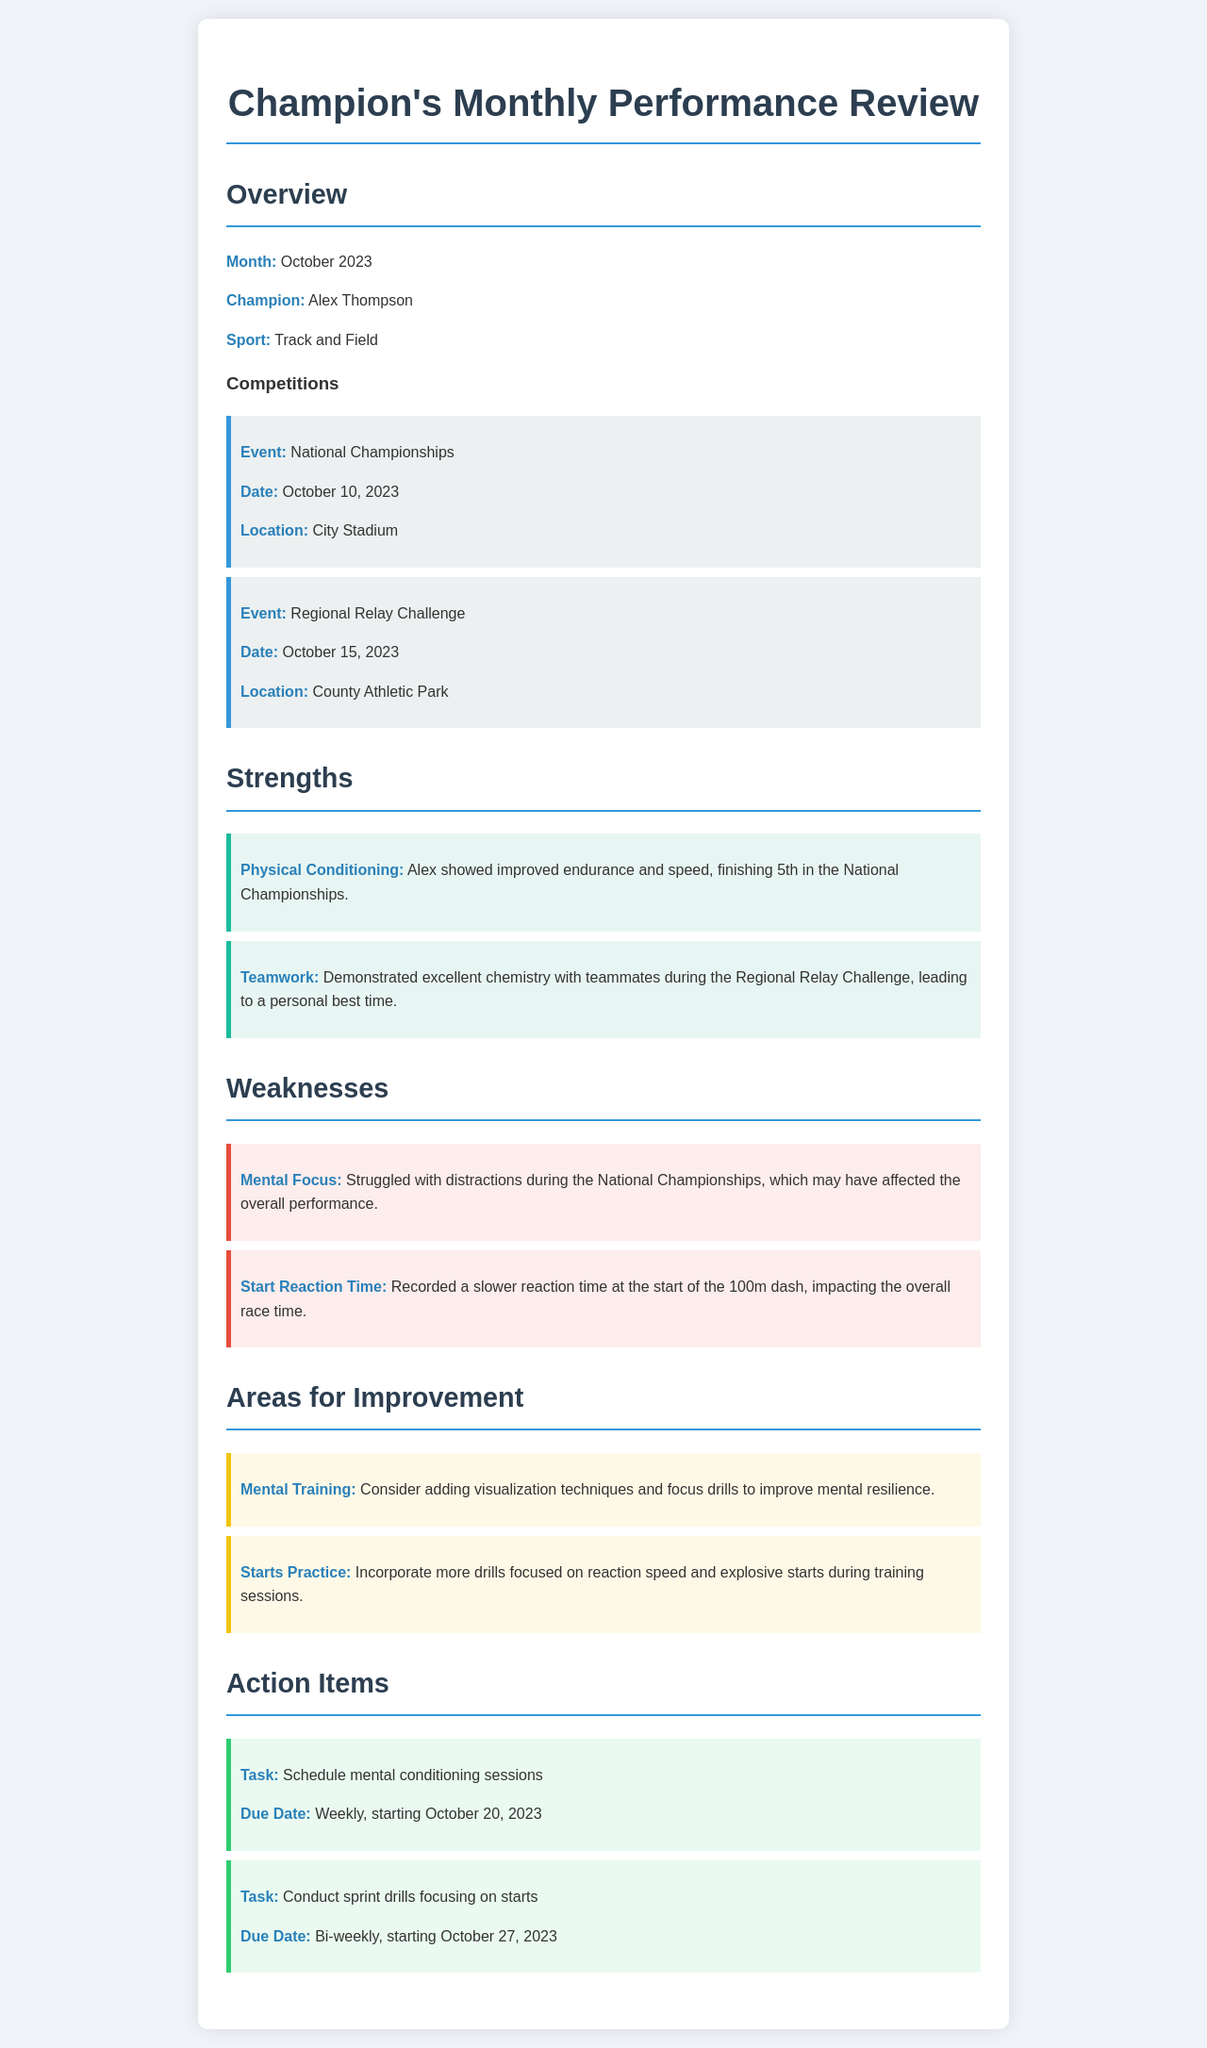What is the name of the champion? The champion's name is mentioned in the overview section of the document.
Answer: Alex Thompson What event did Alex compete in on October 10, 2023? The event includes specific details regarding competitions held, especially the one on October 10.
Answer: National Championships What was Alex's placement at the National Championships? Alex's standing in the National Championships is clearly stated in the strengths section.
Answer: 5th What was identified as a weakness regarding Alex's performance? The weaknesses section lists specific areas where Alex can improve.
Answer: Mental Focus What specific area of improvement involves visualization techniques? The document outlines improvement areas, highlighting specific strategies to enhance performance.
Answer: Mental Training How often are mental conditioning sessions scheduled? The action items section specifies the frequency for different tasks.
Answer: Weekly What location hosted the Regional Relay Challenge? The document specifies the location of each competitive event, including this one.
Answer: County Athletic Park What was noted about Alex's reaction time at the start? The weaknesses section discusses a weakness related to Alex's performance during a race, specifically mentioning reaction time.
Answer: Slower What date is scheduled for the first sprint drill focusing on starts? The due date for action items is provided, including when to start the sprint drills.
Answer: October 27, 2023 